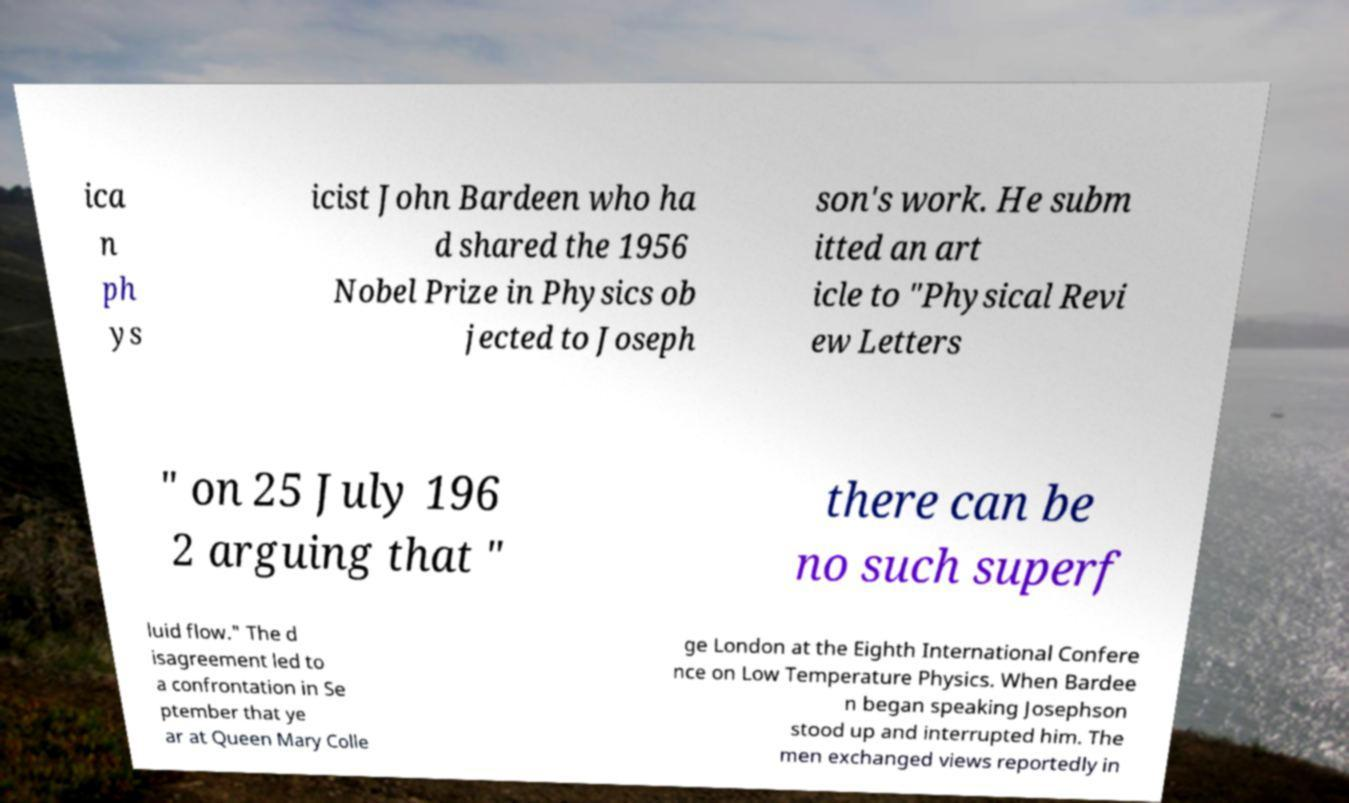Can you accurately transcribe the text from the provided image for me? ica n ph ys icist John Bardeen who ha d shared the 1956 Nobel Prize in Physics ob jected to Joseph son's work. He subm itted an art icle to "Physical Revi ew Letters " on 25 July 196 2 arguing that " there can be no such superf luid flow." The d isagreement led to a confrontation in Se ptember that ye ar at Queen Mary Colle ge London at the Eighth International Confere nce on Low Temperature Physics. When Bardee n began speaking Josephson stood up and interrupted him. The men exchanged views reportedly in 